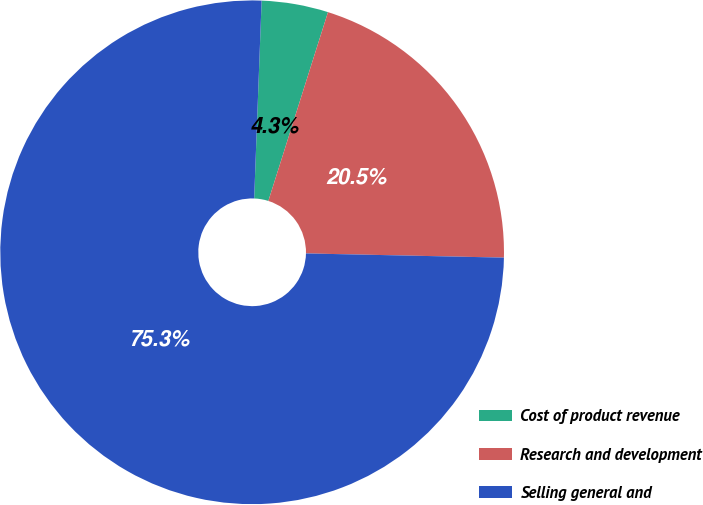Convert chart. <chart><loc_0><loc_0><loc_500><loc_500><pie_chart><fcel>Cost of product revenue<fcel>Research and development<fcel>Selling general and<nl><fcel>4.27%<fcel>20.47%<fcel>75.27%<nl></chart> 